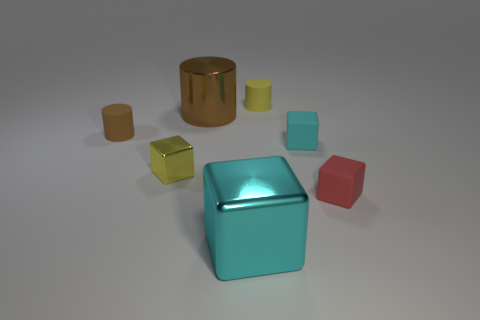Does this image give any indication of the objects' function or purpose? Not explicitly. The image presents a purely aesthetic composition of geometric shapes without any clear indication of their function. They could be interpreted as ornamental or part of an abstract art piece. 